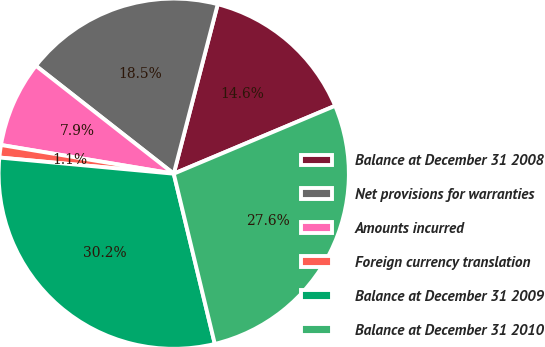<chart> <loc_0><loc_0><loc_500><loc_500><pie_chart><fcel>Balance at December 31 2008<fcel>Net provisions for warranties<fcel>Amounts incurred<fcel>Foreign currency translation<fcel>Balance at December 31 2009<fcel>Balance at December 31 2010<nl><fcel>14.62%<fcel>18.47%<fcel>7.95%<fcel>1.15%<fcel>30.24%<fcel>27.57%<nl></chart> 